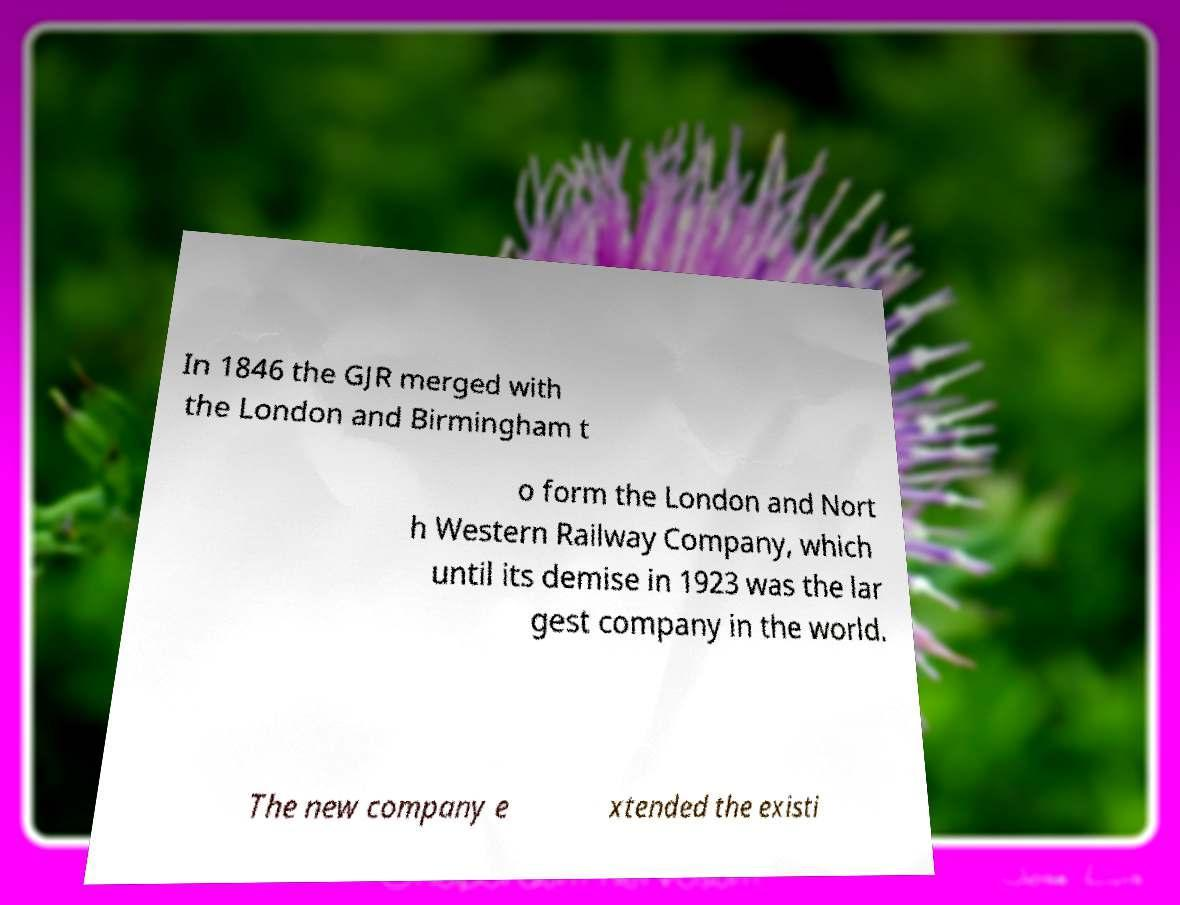Can you read and provide the text displayed in the image?This photo seems to have some interesting text. Can you extract and type it out for me? In 1846 the GJR merged with the London and Birmingham t o form the London and Nort h Western Railway Company, which until its demise in 1923 was the lar gest company in the world. The new company e xtended the existi 